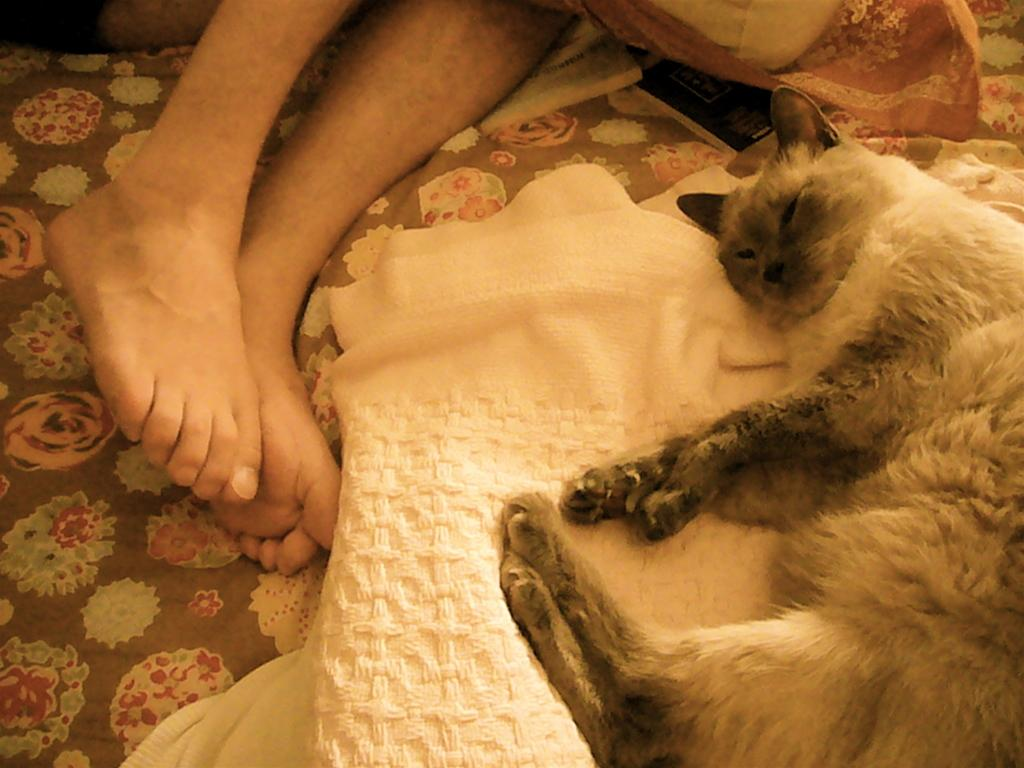What animal can be seen in the image? There is a cat lying on a blanket in the image. What part of a person's body is visible in the image? The legs of a person are visible in the image. What type of blanket is featured in the image? There is a blanket with a design in the image. What sound does the light make in the image? There is no light present in the image, so it cannot make a sound. 